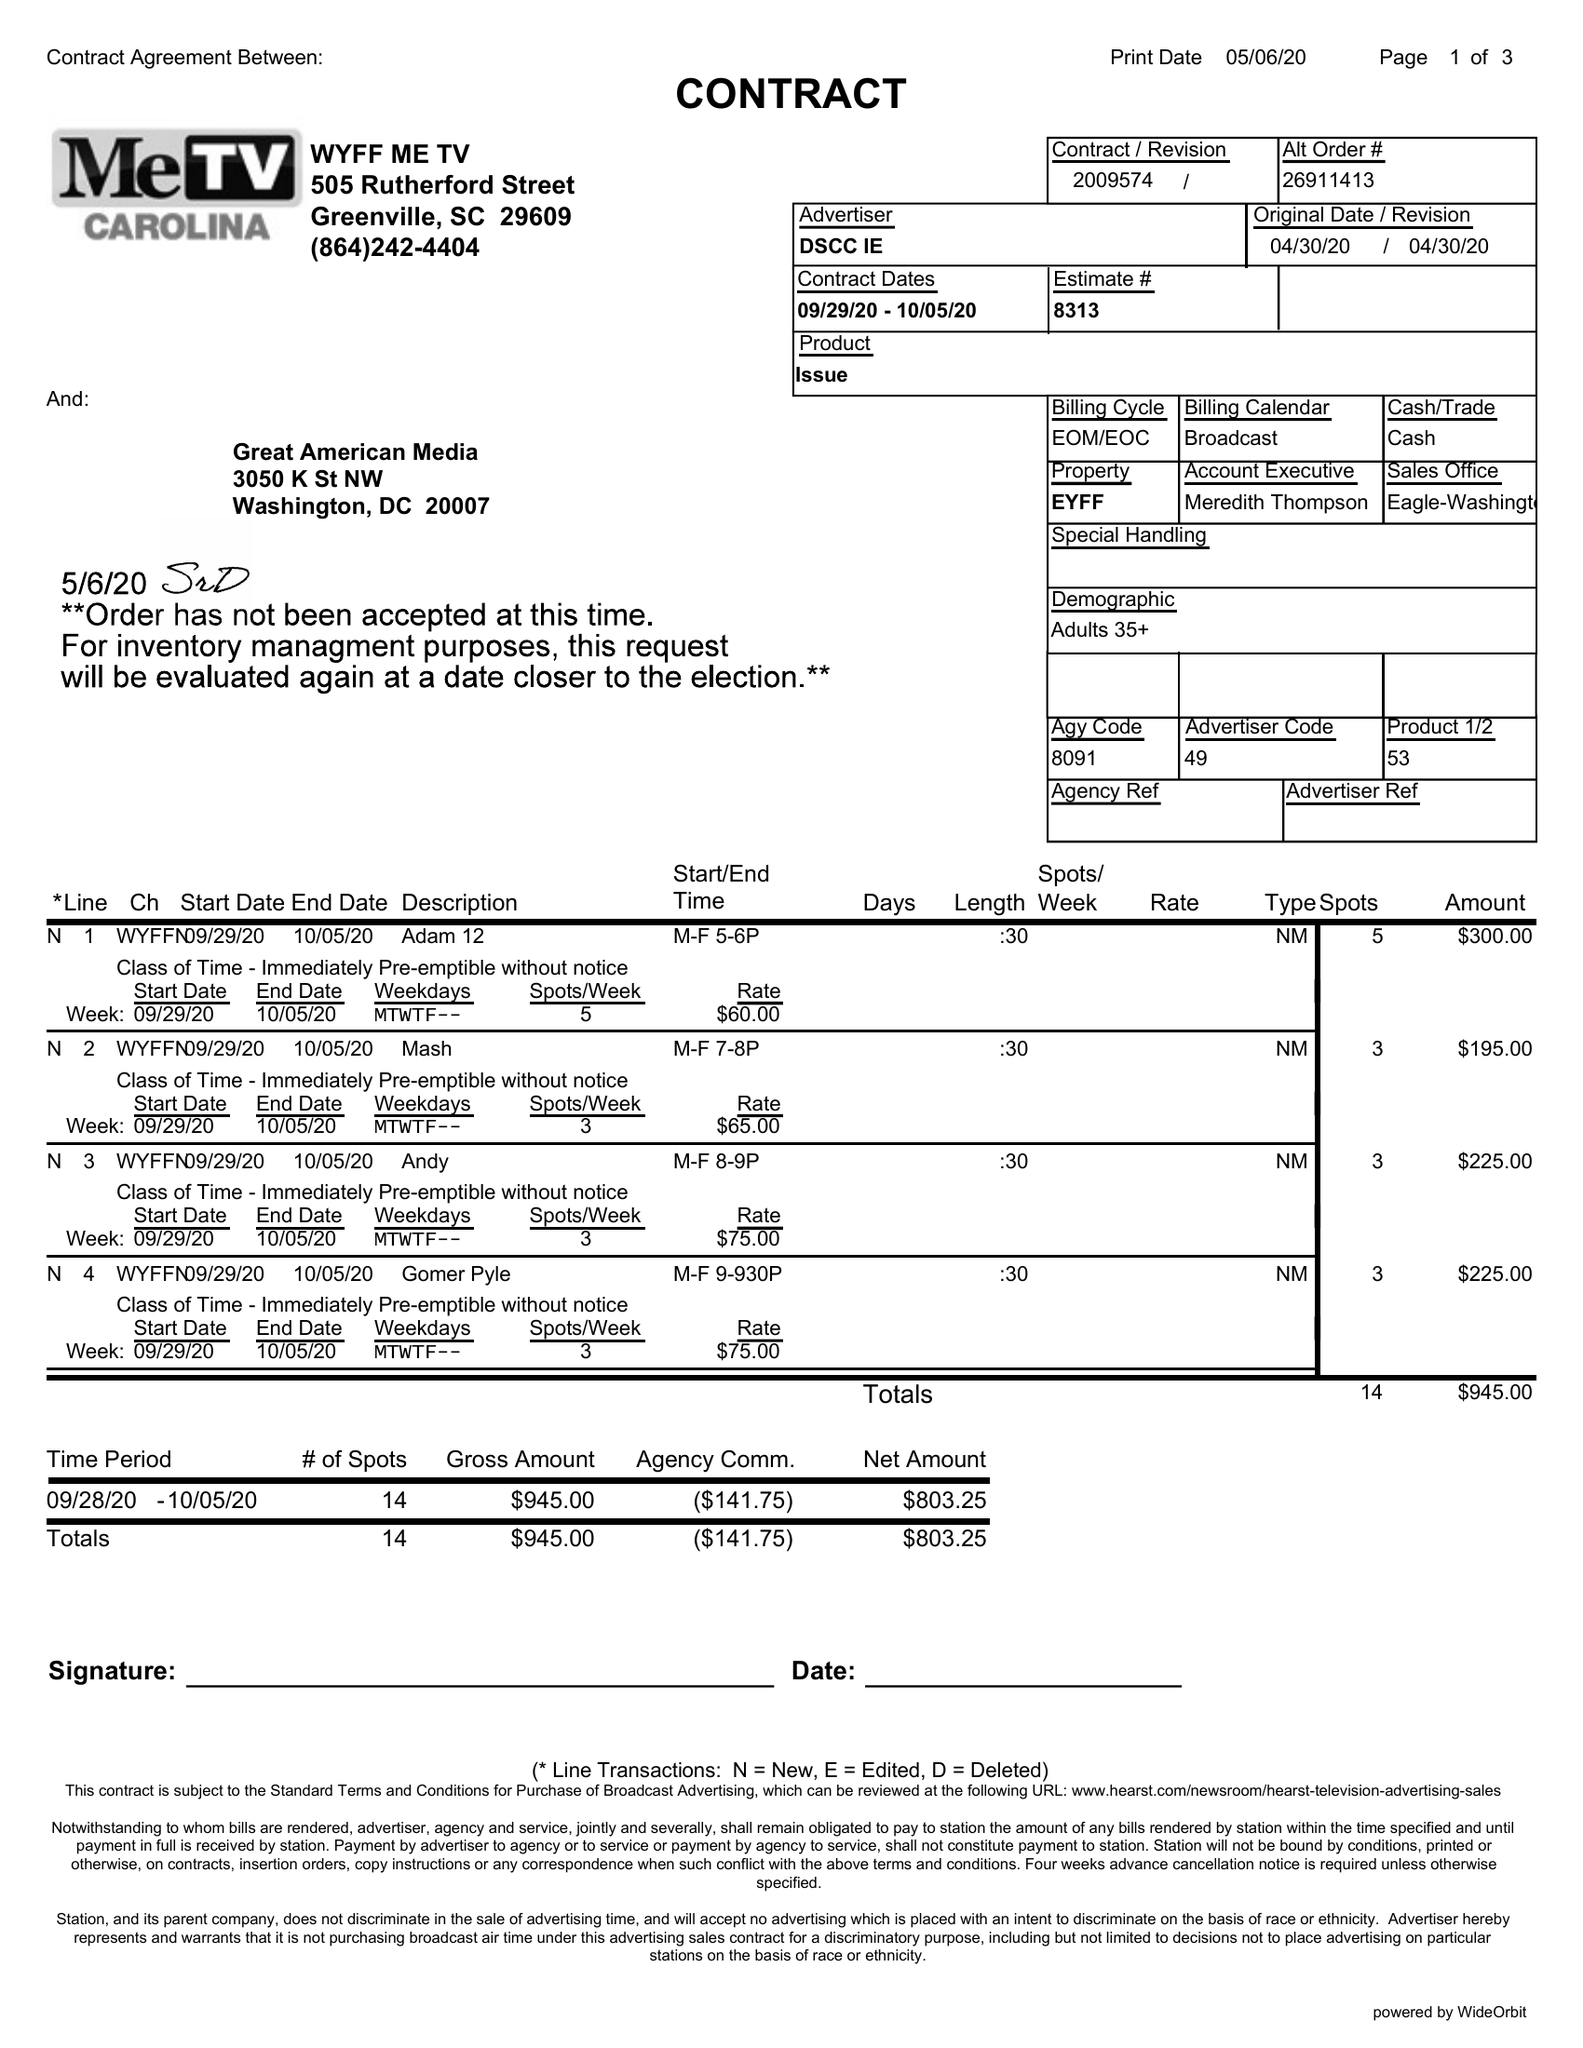What is the value for the flight_to?
Answer the question using a single word or phrase. 10/05/20 